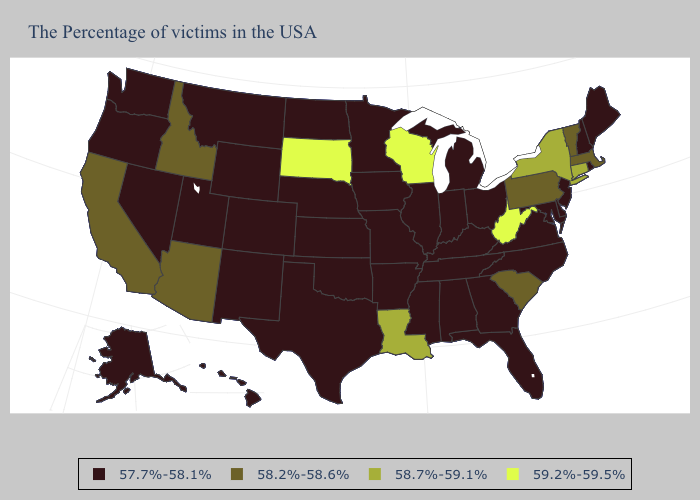What is the value of Connecticut?
Keep it brief. 58.7%-59.1%. What is the highest value in states that border West Virginia?
Be succinct. 58.2%-58.6%. What is the value of North Dakota?
Write a very short answer. 57.7%-58.1%. Does South Dakota have the lowest value in the USA?
Answer briefly. No. Does Indiana have the lowest value in the USA?
Short answer required. Yes. What is the value of Tennessee?
Answer briefly. 57.7%-58.1%. What is the value of Wyoming?
Quick response, please. 57.7%-58.1%. Does Tennessee have the lowest value in the USA?
Keep it brief. Yes. What is the value of Idaho?
Answer briefly. 58.2%-58.6%. Name the states that have a value in the range 58.7%-59.1%?
Keep it brief. Connecticut, New York, Louisiana. Name the states that have a value in the range 58.2%-58.6%?
Keep it brief. Massachusetts, Vermont, Pennsylvania, South Carolina, Arizona, Idaho, California. Name the states that have a value in the range 59.2%-59.5%?
Quick response, please. West Virginia, Wisconsin, South Dakota. What is the highest value in states that border North Dakota?
Quick response, please. 59.2%-59.5%. What is the lowest value in states that border Utah?
Answer briefly. 57.7%-58.1%. 